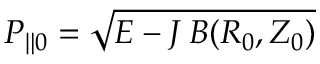Convert formula to latex. <formula><loc_0><loc_0><loc_500><loc_500>P _ { \| 0 } = \sqrt { E - J \, B ( R _ { 0 } , Z _ { 0 } ) }</formula> 